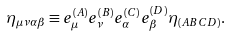<formula> <loc_0><loc_0><loc_500><loc_500>\eta _ { \mu \nu \alpha \beta } \equiv e _ { \mu } ^ { ( A ) } e _ { \nu } ^ { ( B ) } e _ { \alpha } ^ { ( C ) } e _ { \beta } ^ { ( D ) } \eta _ { ( A B C D ) } .</formula> 